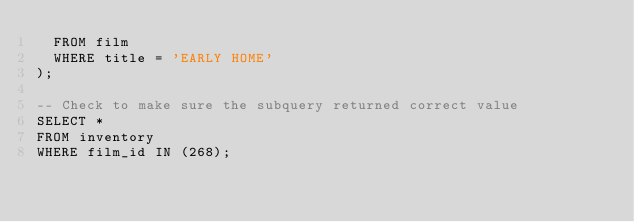<code> <loc_0><loc_0><loc_500><loc_500><_SQL_>  FROM film
  WHERE title = 'EARLY HOME'
);

-- Check to make sure the subquery returned correct value
SELECT *
FROM inventory
WHERE film_id IN (268);
</code> 